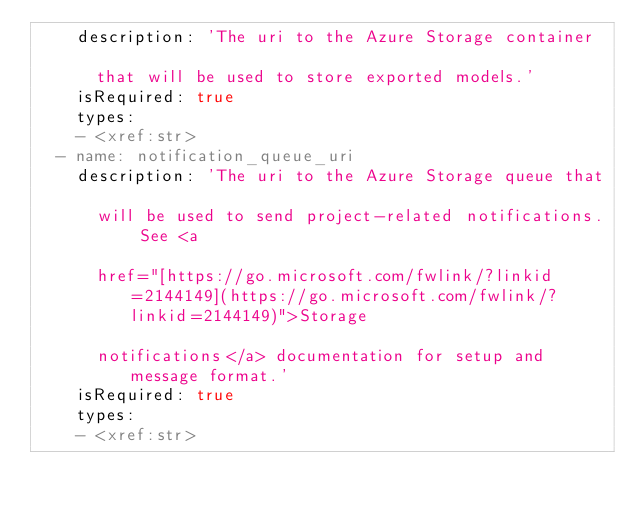<code> <loc_0><loc_0><loc_500><loc_500><_YAML_>    description: 'The uri to the Azure Storage container

      that will be used to store exported models.'
    isRequired: true
    types:
    - <xref:str>
  - name: notification_queue_uri
    description: 'The uri to the Azure Storage queue that

      will be used to send project-related notifications. See <a

      href="[https://go.microsoft.com/fwlink/?linkid=2144149](https://go.microsoft.com/fwlink/?linkid=2144149)">Storage

      notifications</a> documentation for setup and message format.'
    isRequired: true
    types:
    - <xref:str>
</code> 